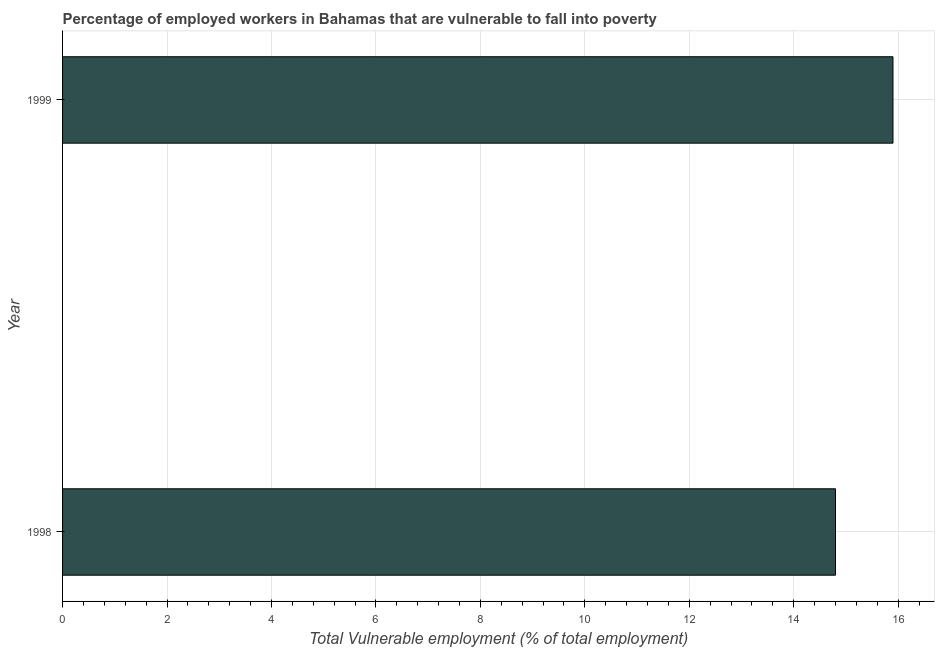Does the graph contain any zero values?
Offer a very short reply. No. What is the title of the graph?
Make the answer very short. Percentage of employed workers in Bahamas that are vulnerable to fall into poverty. What is the label or title of the X-axis?
Give a very brief answer. Total Vulnerable employment (% of total employment). What is the total vulnerable employment in 1999?
Provide a short and direct response. 15.9. Across all years, what is the maximum total vulnerable employment?
Make the answer very short. 15.9. Across all years, what is the minimum total vulnerable employment?
Your response must be concise. 14.8. What is the sum of the total vulnerable employment?
Provide a short and direct response. 30.7. What is the average total vulnerable employment per year?
Give a very brief answer. 15.35. What is the median total vulnerable employment?
Offer a very short reply. 15.35. In how many years, is the total vulnerable employment greater than 12.4 %?
Give a very brief answer. 2. Do a majority of the years between 1999 and 1998 (inclusive) have total vulnerable employment greater than 9.2 %?
Make the answer very short. No. In how many years, is the total vulnerable employment greater than the average total vulnerable employment taken over all years?
Your answer should be compact. 1. Are all the bars in the graph horizontal?
Keep it short and to the point. Yes. What is the difference between two consecutive major ticks on the X-axis?
Offer a terse response. 2. What is the Total Vulnerable employment (% of total employment) of 1998?
Give a very brief answer. 14.8. What is the Total Vulnerable employment (% of total employment) of 1999?
Provide a succinct answer. 15.9. What is the ratio of the Total Vulnerable employment (% of total employment) in 1998 to that in 1999?
Your answer should be very brief. 0.93. 